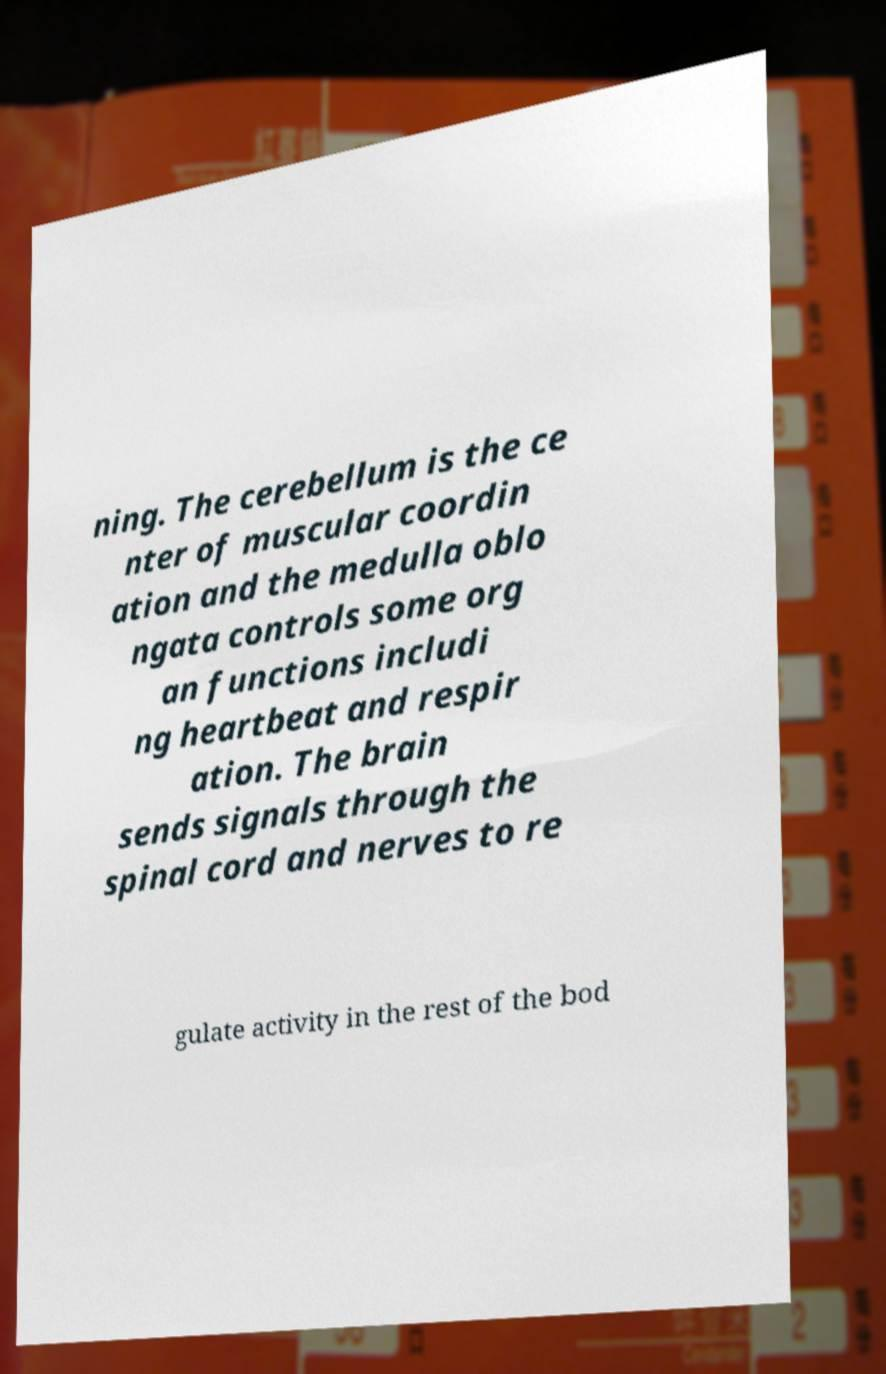What messages or text are displayed in this image? I need them in a readable, typed format. ning. The cerebellum is the ce nter of muscular coordin ation and the medulla oblo ngata controls some org an functions includi ng heartbeat and respir ation. The brain sends signals through the spinal cord and nerves to re gulate activity in the rest of the bod 